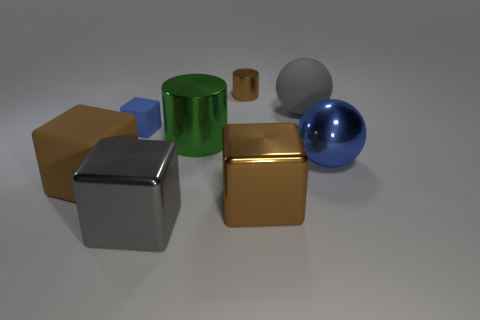Do the big metal sphere and the large matte sphere have the same color?
Your answer should be very brief. No. There is a big object that is both on the left side of the tiny brown metal cylinder and behind the big brown rubber block; what color is it?
Offer a very short reply. Green. What number of spheres are small metallic things or big things?
Make the answer very short. 2. Is the number of big brown shiny cubes behind the big green cylinder less than the number of small cubes?
Provide a succinct answer. Yes. The big brown thing that is the same material as the blue ball is what shape?
Ensure brevity in your answer.  Cube. How many other large metallic cylinders have the same color as the large metallic cylinder?
Your answer should be very brief. 0. What number of things are brown metal objects or big objects?
Keep it short and to the point. 7. There is a large ball right of the large gray object behind the blue rubber thing; what is it made of?
Give a very brief answer. Metal. Is there a tiny brown thing that has the same material as the small brown cylinder?
Offer a terse response. No. What is the shape of the brown thing on the left side of the gray thing that is in front of the large brown thing to the right of the brown rubber object?
Your response must be concise. Cube. 